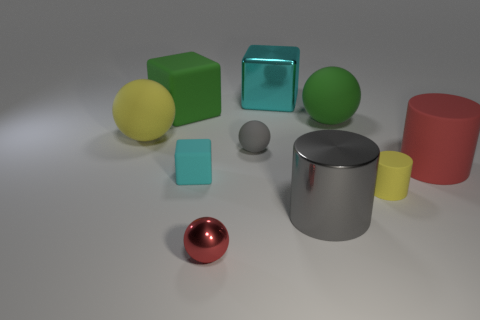What number of other objects are there of the same size as the green matte block?
Make the answer very short. 5. Does the big metal cylinder have the same color as the matte thing left of the green block?
Offer a terse response. No. What number of spheres are big red objects or cyan objects?
Offer a terse response. 0. Are there any other things that are the same color as the large matte block?
Make the answer very short. Yes. What material is the small cylinder that is in front of the small thing on the left side of the red shiny object made of?
Ensure brevity in your answer.  Rubber. Do the tiny gray sphere and the ball that is right of the cyan metal cube have the same material?
Make the answer very short. Yes. How many things are yellow rubber things to the left of the gray sphere or big cyan things?
Make the answer very short. 2. Are there any cylinders that have the same color as the tiny rubber ball?
Offer a terse response. Yes. Is the shape of the big cyan thing the same as the small thing on the right side of the large gray metallic thing?
Provide a succinct answer. No. What number of objects are in front of the gray cylinder and to the left of the tiny rubber block?
Keep it short and to the point. 0. 